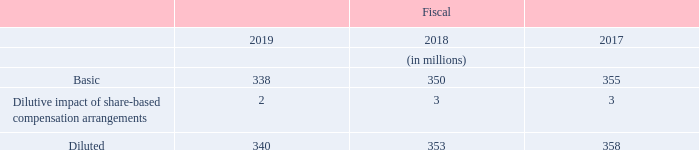16. Earnings Per Share
The weighted-average number of shares outstanding used in the computations of basic and diluted earnings per share were as follows:
In which years was the basic earnings per share calculated for? 2019, 2018, 2017. What was used in the computations of basic and diluted earnings per share? The weighted-average number of shares outstanding. What are the types of earnings per share analyzed in the table? Basic, diluted. Which year was the basic earnings per share the largest? 355>350>338
Answer: 2017. What was the change in Dilutive impact of share-based compensation arrangements in 2019 from 2018?
Answer scale should be: million. 2-3
Answer: -1. What was the percentage change in Dilutive impact of share-based compensation arrangements in 2019 from 2018?
Answer scale should be: percent. (2-3)/3
Answer: -33.33. 